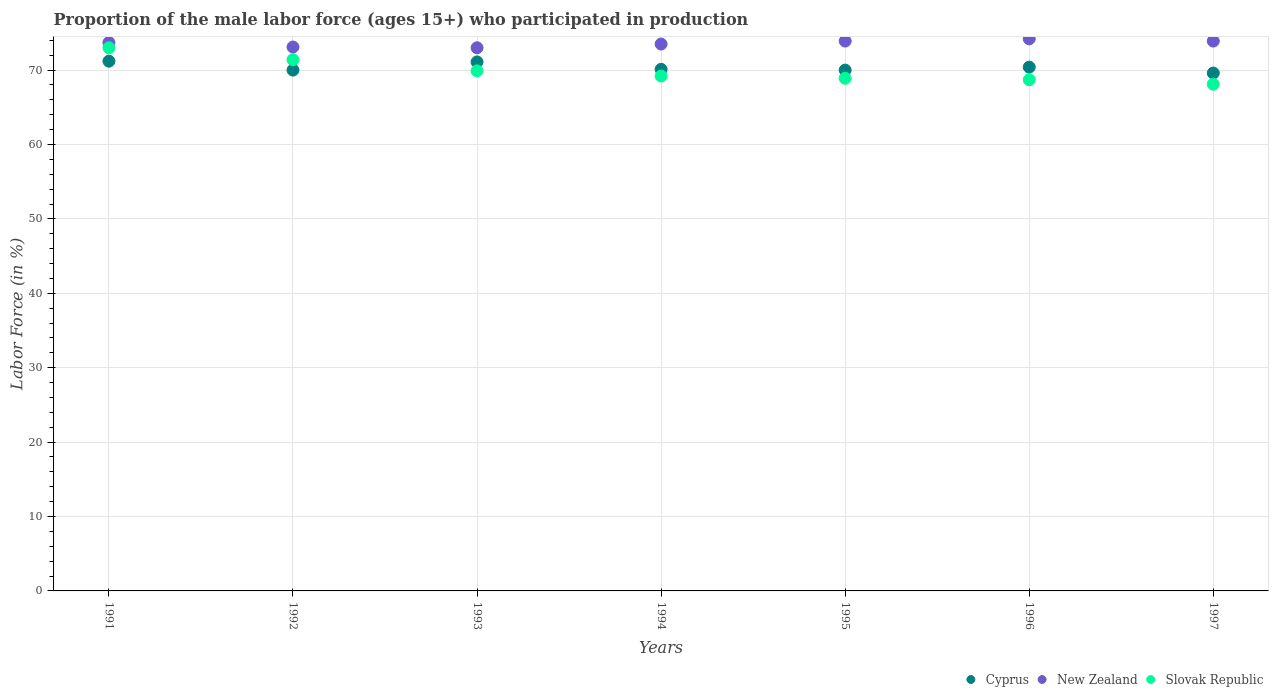How many different coloured dotlines are there?
Your response must be concise. 3. Is the number of dotlines equal to the number of legend labels?
Your answer should be compact. Yes. Across all years, what is the maximum proportion of the male labor force who participated in production in Cyprus?
Provide a short and direct response. 71.2. Across all years, what is the minimum proportion of the male labor force who participated in production in Slovak Republic?
Give a very brief answer. 68.1. In which year was the proportion of the male labor force who participated in production in New Zealand minimum?
Your answer should be compact. 1993. What is the total proportion of the male labor force who participated in production in Cyprus in the graph?
Offer a terse response. 492.4. What is the difference between the proportion of the male labor force who participated in production in Slovak Republic in 1991 and that in 1994?
Ensure brevity in your answer.  3.8. What is the difference between the proportion of the male labor force who participated in production in Slovak Republic in 1992 and the proportion of the male labor force who participated in production in New Zealand in 1996?
Offer a terse response. -2.8. What is the average proportion of the male labor force who participated in production in New Zealand per year?
Make the answer very short. 73.61. In the year 1995, what is the difference between the proportion of the male labor force who participated in production in Slovak Republic and proportion of the male labor force who participated in production in Cyprus?
Offer a terse response. -1.1. In how many years, is the proportion of the male labor force who participated in production in Cyprus greater than 54 %?
Ensure brevity in your answer.  7. What is the ratio of the proportion of the male labor force who participated in production in Slovak Republic in 1991 to that in 1992?
Offer a terse response. 1.02. Is the proportion of the male labor force who participated in production in New Zealand in 1995 less than that in 1997?
Your answer should be compact. No. Is the difference between the proportion of the male labor force who participated in production in Slovak Republic in 1991 and 1997 greater than the difference between the proportion of the male labor force who participated in production in Cyprus in 1991 and 1997?
Keep it short and to the point. Yes. What is the difference between the highest and the second highest proportion of the male labor force who participated in production in New Zealand?
Give a very brief answer. 0.3. What is the difference between the highest and the lowest proportion of the male labor force who participated in production in New Zealand?
Give a very brief answer. 1.2. Is the sum of the proportion of the male labor force who participated in production in New Zealand in 1994 and 1995 greater than the maximum proportion of the male labor force who participated in production in Cyprus across all years?
Make the answer very short. Yes. Does the proportion of the male labor force who participated in production in New Zealand monotonically increase over the years?
Offer a terse response. No. Is the proportion of the male labor force who participated in production in New Zealand strictly greater than the proportion of the male labor force who participated in production in Slovak Republic over the years?
Your response must be concise. Yes. Is the proportion of the male labor force who participated in production in Cyprus strictly less than the proportion of the male labor force who participated in production in New Zealand over the years?
Provide a short and direct response. Yes. How many years are there in the graph?
Give a very brief answer. 7. What is the title of the graph?
Your answer should be compact. Proportion of the male labor force (ages 15+) who participated in production. What is the label or title of the X-axis?
Make the answer very short. Years. What is the label or title of the Y-axis?
Provide a short and direct response. Labor Force (in %). What is the Labor Force (in %) in Cyprus in 1991?
Provide a succinct answer. 71.2. What is the Labor Force (in %) in New Zealand in 1991?
Ensure brevity in your answer.  73.7. What is the Labor Force (in %) in Slovak Republic in 1991?
Offer a terse response. 73. What is the Labor Force (in %) in New Zealand in 1992?
Offer a very short reply. 73.1. What is the Labor Force (in %) in Slovak Republic in 1992?
Your answer should be very brief. 71.4. What is the Labor Force (in %) of Cyprus in 1993?
Make the answer very short. 71.1. What is the Labor Force (in %) of Slovak Republic in 1993?
Provide a short and direct response. 69.9. What is the Labor Force (in %) in Cyprus in 1994?
Make the answer very short. 70.1. What is the Labor Force (in %) of New Zealand in 1994?
Offer a very short reply. 73.5. What is the Labor Force (in %) in Slovak Republic in 1994?
Provide a succinct answer. 69.2. What is the Labor Force (in %) of Cyprus in 1995?
Make the answer very short. 70. What is the Labor Force (in %) of New Zealand in 1995?
Make the answer very short. 73.9. What is the Labor Force (in %) in Slovak Republic in 1995?
Give a very brief answer. 68.9. What is the Labor Force (in %) of Cyprus in 1996?
Make the answer very short. 70.4. What is the Labor Force (in %) in New Zealand in 1996?
Your answer should be compact. 74.2. What is the Labor Force (in %) in Slovak Republic in 1996?
Make the answer very short. 68.7. What is the Labor Force (in %) of Cyprus in 1997?
Make the answer very short. 69.6. What is the Labor Force (in %) of New Zealand in 1997?
Your response must be concise. 73.9. What is the Labor Force (in %) in Slovak Republic in 1997?
Ensure brevity in your answer.  68.1. Across all years, what is the maximum Labor Force (in %) of Cyprus?
Offer a very short reply. 71.2. Across all years, what is the maximum Labor Force (in %) of New Zealand?
Ensure brevity in your answer.  74.2. Across all years, what is the maximum Labor Force (in %) in Slovak Republic?
Offer a terse response. 73. Across all years, what is the minimum Labor Force (in %) of Cyprus?
Your response must be concise. 69.6. Across all years, what is the minimum Labor Force (in %) of New Zealand?
Provide a short and direct response. 73. Across all years, what is the minimum Labor Force (in %) in Slovak Republic?
Your answer should be very brief. 68.1. What is the total Labor Force (in %) in Cyprus in the graph?
Ensure brevity in your answer.  492.4. What is the total Labor Force (in %) in New Zealand in the graph?
Provide a succinct answer. 515.3. What is the total Labor Force (in %) in Slovak Republic in the graph?
Keep it short and to the point. 489.2. What is the difference between the Labor Force (in %) in Cyprus in 1991 and that in 1992?
Keep it short and to the point. 1.2. What is the difference between the Labor Force (in %) of New Zealand in 1991 and that in 1992?
Ensure brevity in your answer.  0.6. What is the difference between the Labor Force (in %) in Slovak Republic in 1991 and that in 1993?
Provide a succinct answer. 3.1. What is the difference between the Labor Force (in %) of Cyprus in 1991 and that in 1994?
Your answer should be very brief. 1.1. What is the difference between the Labor Force (in %) of Slovak Republic in 1991 and that in 1994?
Ensure brevity in your answer.  3.8. What is the difference between the Labor Force (in %) of Cyprus in 1991 and that in 1995?
Your answer should be compact. 1.2. What is the difference between the Labor Force (in %) of Cyprus in 1991 and that in 1996?
Make the answer very short. 0.8. What is the difference between the Labor Force (in %) of New Zealand in 1991 and that in 1996?
Give a very brief answer. -0.5. What is the difference between the Labor Force (in %) of Slovak Republic in 1991 and that in 1996?
Give a very brief answer. 4.3. What is the difference between the Labor Force (in %) of Slovak Republic in 1991 and that in 1997?
Your answer should be compact. 4.9. What is the difference between the Labor Force (in %) in New Zealand in 1992 and that in 1993?
Provide a short and direct response. 0.1. What is the difference between the Labor Force (in %) of Slovak Republic in 1992 and that in 1993?
Offer a terse response. 1.5. What is the difference between the Labor Force (in %) in Cyprus in 1992 and that in 1994?
Your answer should be compact. -0.1. What is the difference between the Labor Force (in %) of Cyprus in 1992 and that in 1995?
Ensure brevity in your answer.  0. What is the difference between the Labor Force (in %) in New Zealand in 1992 and that in 1995?
Your answer should be very brief. -0.8. What is the difference between the Labor Force (in %) in Cyprus in 1992 and that in 1996?
Ensure brevity in your answer.  -0.4. What is the difference between the Labor Force (in %) of New Zealand in 1992 and that in 1996?
Ensure brevity in your answer.  -1.1. What is the difference between the Labor Force (in %) in Slovak Republic in 1992 and that in 1996?
Offer a very short reply. 2.7. What is the difference between the Labor Force (in %) in Cyprus in 1992 and that in 1997?
Keep it short and to the point. 0.4. What is the difference between the Labor Force (in %) of New Zealand in 1992 and that in 1997?
Give a very brief answer. -0.8. What is the difference between the Labor Force (in %) of Slovak Republic in 1992 and that in 1997?
Your answer should be very brief. 3.3. What is the difference between the Labor Force (in %) in New Zealand in 1993 and that in 1994?
Offer a very short reply. -0.5. What is the difference between the Labor Force (in %) of Cyprus in 1993 and that in 1995?
Offer a very short reply. 1.1. What is the difference between the Labor Force (in %) in Slovak Republic in 1993 and that in 1995?
Offer a very short reply. 1. What is the difference between the Labor Force (in %) of Cyprus in 1993 and that in 1996?
Ensure brevity in your answer.  0.7. What is the difference between the Labor Force (in %) in Cyprus in 1994 and that in 1995?
Your response must be concise. 0.1. What is the difference between the Labor Force (in %) of Cyprus in 1994 and that in 1996?
Provide a succinct answer. -0.3. What is the difference between the Labor Force (in %) of Slovak Republic in 1994 and that in 1997?
Give a very brief answer. 1.1. What is the difference between the Labor Force (in %) in New Zealand in 1995 and that in 1996?
Your answer should be very brief. -0.3. What is the difference between the Labor Force (in %) in Slovak Republic in 1995 and that in 1996?
Offer a very short reply. 0.2. What is the difference between the Labor Force (in %) in Cyprus in 1996 and that in 1997?
Your answer should be compact. 0.8. What is the difference between the Labor Force (in %) in Slovak Republic in 1996 and that in 1997?
Keep it short and to the point. 0.6. What is the difference between the Labor Force (in %) of New Zealand in 1991 and the Labor Force (in %) of Slovak Republic in 1993?
Your answer should be compact. 3.8. What is the difference between the Labor Force (in %) in Cyprus in 1991 and the Labor Force (in %) in New Zealand in 1994?
Provide a short and direct response. -2.3. What is the difference between the Labor Force (in %) of New Zealand in 1991 and the Labor Force (in %) of Slovak Republic in 1994?
Offer a very short reply. 4.5. What is the difference between the Labor Force (in %) in Cyprus in 1991 and the Labor Force (in %) in Slovak Republic in 1995?
Ensure brevity in your answer.  2.3. What is the difference between the Labor Force (in %) of Cyprus in 1991 and the Labor Force (in %) of New Zealand in 1996?
Provide a succinct answer. -3. What is the difference between the Labor Force (in %) of Cyprus in 1991 and the Labor Force (in %) of New Zealand in 1997?
Your answer should be very brief. -2.7. What is the difference between the Labor Force (in %) of New Zealand in 1991 and the Labor Force (in %) of Slovak Republic in 1997?
Offer a terse response. 5.6. What is the difference between the Labor Force (in %) in Cyprus in 1992 and the Labor Force (in %) in New Zealand in 1993?
Provide a short and direct response. -3. What is the difference between the Labor Force (in %) of New Zealand in 1992 and the Labor Force (in %) of Slovak Republic in 1993?
Your response must be concise. 3.2. What is the difference between the Labor Force (in %) of Cyprus in 1992 and the Labor Force (in %) of Slovak Republic in 1994?
Keep it short and to the point. 0.8. What is the difference between the Labor Force (in %) of New Zealand in 1992 and the Labor Force (in %) of Slovak Republic in 1994?
Provide a succinct answer. 3.9. What is the difference between the Labor Force (in %) of Cyprus in 1992 and the Labor Force (in %) of Slovak Republic in 1995?
Keep it short and to the point. 1.1. What is the difference between the Labor Force (in %) of Cyprus in 1992 and the Labor Force (in %) of New Zealand in 1996?
Keep it short and to the point. -4.2. What is the difference between the Labor Force (in %) of New Zealand in 1992 and the Labor Force (in %) of Slovak Republic in 1996?
Offer a very short reply. 4.4. What is the difference between the Labor Force (in %) in New Zealand in 1992 and the Labor Force (in %) in Slovak Republic in 1997?
Ensure brevity in your answer.  5. What is the difference between the Labor Force (in %) in Cyprus in 1993 and the Labor Force (in %) in New Zealand in 1994?
Provide a succinct answer. -2.4. What is the difference between the Labor Force (in %) of New Zealand in 1993 and the Labor Force (in %) of Slovak Republic in 1994?
Keep it short and to the point. 3.8. What is the difference between the Labor Force (in %) in Cyprus in 1993 and the Labor Force (in %) in New Zealand in 1995?
Offer a very short reply. -2.8. What is the difference between the Labor Force (in %) of New Zealand in 1993 and the Labor Force (in %) of Slovak Republic in 1995?
Ensure brevity in your answer.  4.1. What is the difference between the Labor Force (in %) in Cyprus in 1993 and the Labor Force (in %) in Slovak Republic in 1996?
Make the answer very short. 2.4. What is the difference between the Labor Force (in %) of New Zealand in 1993 and the Labor Force (in %) of Slovak Republic in 1996?
Keep it short and to the point. 4.3. What is the difference between the Labor Force (in %) of New Zealand in 1993 and the Labor Force (in %) of Slovak Republic in 1997?
Offer a terse response. 4.9. What is the difference between the Labor Force (in %) of Cyprus in 1994 and the Labor Force (in %) of New Zealand in 1995?
Provide a succinct answer. -3.8. What is the difference between the Labor Force (in %) of Cyprus in 1994 and the Labor Force (in %) of Slovak Republic in 1995?
Keep it short and to the point. 1.2. What is the difference between the Labor Force (in %) of New Zealand in 1994 and the Labor Force (in %) of Slovak Republic in 1996?
Provide a short and direct response. 4.8. What is the difference between the Labor Force (in %) of Cyprus in 1994 and the Labor Force (in %) of New Zealand in 1997?
Your answer should be compact. -3.8. What is the difference between the Labor Force (in %) in New Zealand in 1994 and the Labor Force (in %) in Slovak Republic in 1997?
Provide a short and direct response. 5.4. What is the difference between the Labor Force (in %) in Cyprus in 1995 and the Labor Force (in %) in New Zealand in 1996?
Your response must be concise. -4.2. What is the difference between the Labor Force (in %) in New Zealand in 1995 and the Labor Force (in %) in Slovak Republic in 1996?
Keep it short and to the point. 5.2. What is the difference between the Labor Force (in %) of Cyprus in 1995 and the Labor Force (in %) of New Zealand in 1997?
Keep it short and to the point. -3.9. What is the difference between the Labor Force (in %) of Cyprus in 1995 and the Labor Force (in %) of Slovak Republic in 1997?
Your response must be concise. 1.9. What is the average Labor Force (in %) of Cyprus per year?
Your answer should be very brief. 70.34. What is the average Labor Force (in %) of New Zealand per year?
Your response must be concise. 73.61. What is the average Labor Force (in %) in Slovak Republic per year?
Give a very brief answer. 69.89. In the year 1991, what is the difference between the Labor Force (in %) of Cyprus and Labor Force (in %) of New Zealand?
Offer a terse response. -2.5. In the year 1991, what is the difference between the Labor Force (in %) of Cyprus and Labor Force (in %) of Slovak Republic?
Keep it short and to the point. -1.8. In the year 1992, what is the difference between the Labor Force (in %) of Cyprus and Labor Force (in %) of Slovak Republic?
Your answer should be very brief. -1.4. In the year 1993, what is the difference between the Labor Force (in %) in Cyprus and Labor Force (in %) in New Zealand?
Offer a very short reply. -1.9. In the year 1993, what is the difference between the Labor Force (in %) of Cyprus and Labor Force (in %) of Slovak Republic?
Keep it short and to the point. 1.2. In the year 1993, what is the difference between the Labor Force (in %) in New Zealand and Labor Force (in %) in Slovak Republic?
Offer a very short reply. 3.1. In the year 1994, what is the difference between the Labor Force (in %) in Cyprus and Labor Force (in %) in New Zealand?
Offer a very short reply. -3.4. In the year 1994, what is the difference between the Labor Force (in %) in New Zealand and Labor Force (in %) in Slovak Republic?
Make the answer very short. 4.3. In the year 1995, what is the difference between the Labor Force (in %) of Cyprus and Labor Force (in %) of Slovak Republic?
Your response must be concise. 1.1. In the year 1995, what is the difference between the Labor Force (in %) of New Zealand and Labor Force (in %) of Slovak Republic?
Offer a very short reply. 5. In the year 1996, what is the difference between the Labor Force (in %) of Cyprus and Labor Force (in %) of Slovak Republic?
Keep it short and to the point. 1.7. In the year 1996, what is the difference between the Labor Force (in %) of New Zealand and Labor Force (in %) of Slovak Republic?
Provide a short and direct response. 5.5. In the year 1997, what is the difference between the Labor Force (in %) of Cyprus and Labor Force (in %) of New Zealand?
Offer a terse response. -4.3. In the year 1997, what is the difference between the Labor Force (in %) in New Zealand and Labor Force (in %) in Slovak Republic?
Offer a very short reply. 5.8. What is the ratio of the Labor Force (in %) in Cyprus in 1991 to that in 1992?
Offer a terse response. 1.02. What is the ratio of the Labor Force (in %) in New Zealand in 1991 to that in 1992?
Provide a succinct answer. 1.01. What is the ratio of the Labor Force (in %) in Slovak Republic in 1991 to that in 1992?
Your answer should be compact. 1.02. What is the ratio of the Labor Force (in %) of New Zealand in 1991 to that in 1993?
Make the answer very short. 1.01. What is the ratio of the Labor Force (in %) in Slovak Republic in 1991 to that in 1993?
Your answer should be very brief. 1.04. What is the ratio of the Labor Force (in %) of Cyprus in 1991 to that in 1994?
Provide a short and direct response. 1.02. What is the ratio of the Labor Force (in %) of New Zealand in 1991 to that in 1994?
Offer a terse response. 1. What is the ratio of the Labor Force (in %) in Slovak Republic in 1991 to that in 1994?
Give a very brief answer. 1.05. What is the ratio of the Labor Force (in %) of Cyprus in 1991 to that in 1995?
Offer a very short reply. 1.02. What is the ratio of the Labor Force (in %) in New Zealand in 1991 to that in 1995?
Make the answer very short. 1. What is the ratio of the Labor Force (in %) in Slovak Republic in 1991 to that in 1995?
Your response must be concise. 1.06. What is the ratio of the Labor Force (in %) in Cyprus in 1991 to that in 1996?
Give a very brief answer. 1.01. What is the ratio of the Labor Force (in %) in New Zealand in 1991 to that in 1996?
Give a very brief answer. 0.99. What is the ratio of the Labor Force (in %) of Slovak Republic in 1991 to that in 1996?
Your response must be concise. 1.06. What is the ratio of the Labor Force (in %) of New Zealand in 1991 to that in 1997?
Give a very brief answer. 1. What is the ratio of the Labor Force (in %) in Slovak Republic in 1991 to that in 1997?
Your answer should be compact. 1.07. What is the ratio of the Labor Force (in %) in Cyprus in 1992 to that in 1993?
Provide a succinct answer. 0.98. What is the ratio of the Labor Force (in %) of New Zealand in 1992 to that in 1993?
Offer a very short reply. 1. What is the ratio of the Labor Force (in %) of Slovak Republic in 1992 to that in 1993?
Your response must be concise. 1.02. What is the ratio of the Labor Force (in %) in Cyprus in 1992 to that in 1994?
Your answer should be compact. 1. What is the ratio of the Labor Force (in %) of Slovak Republic in 1992 to that in 1994?
Provide a succinct answer. 1.03. What is the ratio of the Labor Force (in %) in Cyprus in 1992 to that in 1995?
Keep it short and to the point. 1. What is the ratio of the Labor Force (in %) in New Zealand in 1992 to that in 1995?
Your answer should be compact. 0.99. What is the ratio of the Labor Force (in %) of Slovak Republic in 1992 to that in 1995?
Provide a short and direct response. 1.04. What is the ratio of the Labor Force (in %) in Cyprus in 1992 to that in 1996?
Provide a succinct answer. 0.99. What is the ratio of the Labor Force (in %) of New Zealand in 1992 to that in 1996?
Offer a terse response. 0.99. What is the ratio of the Labor Force (in %) in Slovak Republic in 1992 to that in 1996?
Offer a terse response. 1.04. What is the ratio of the Labor Force (in %) in New Zealand in 1992 to that in 1997?
Your answer should be very brief. 0.99. What is the ratio of the Labor Force (in %) of Slovak Republic in 1992 to that in 1997?
Offer a terse response. 1.05. What is the ratio of the Labor Force (in %) of Cyprus in 1993 to that in 1994?
Offer a terse response. 1.01. What is the ratio of the Labor Force (in %) in New Zealand in 1993 to that in 1994?
Keep it short and to the point. 0.99. What is the ratio of the Labor Force (in %) in Cyprus in 1993 to that in 1995?
Ensure brevity in your answer.  1.02. What is the ratio of the Labor Force (in %) in Slovak Republic in 1993 to that in 1995?
Offer a very short reply. 1.01. What is the ratio of the Labor Force (in %) in Cyprus in 1993 to that in 1996?
Offer a terse response. 1.01. What is the ratio of the Labor Force (in %) in New Zealand in 1993 to that in 1996?
Your answer should be compact. 0.98. What is the ratio of the Labor Force (in %) of Slovak Republic in 1993 to that in 1996?
Offer a very short reply. 1.02. What is the ratio of the Labor Force (in %) in Cyprus in 1993 to that in 1997?
Keep it short and to the point. 1.02. What is the ratio of the Labor Force (in %) of Slovak Republic in 1993 to that in 1997?
Provide a short and direct response. 1.03. What is the ratio of the Labor Force (in %) in Cyprus in 1994 to that in 1995?
Your answer should be very brief. 1. What is the ratio of the Labor Force (in %) of Cyprus in 1994 to that in 1996?
Your answer should be compact. 1. What is the ratio of the Labor Force (in %) of New Zealand in 1994 to that in 1996?
Provide a succinct answer. 0.99. What is the ratio of the Labor Force (in %) of Slovak Republic in 1994 to that in 1996?
Offer a terse response. 1.01. What is the ratio of the Labor Force (in %) of Cyprus in 1994 to that in 1997?
Offer a terse response. 1.01. What is the ratio of the Labor Force (in %) of Slovak Republic in 1994 to that in 1997?
Offer a very short reply. 1.02. What is the ratio of the Labor Force (in %) of New Zealand in 1995 to that in 1996?
Ensure brevity in your answer.  1. What is the ratio of the Labor Force (in %) of Slovak Republic in 1995 to that in 1996?
Provide a succinct answer. 1. What is the ratio of the Labor Force (in %) in Cyprus in 1995 to that in 1997?
Give a very brief answer. 1.01. What is the ratio of the Labor Force (in %) in Slovak Republic in 1995 to that in 1997?
Offer a terse response. 1.01. What is the ratio of the Labor Force (in %) of Cyprus in 1996 to that in 1997?
Keep it short and to the point. 1.01. What is the ratio of the Labor Force (in %) in New Zealand in 1996 to that in 1997?
Your answer should be very brief. 1. What is the ratio of the Labor Force (in %) in Slovak Republic in 1996 to that in 1997?
Your answer should be compact. 1.01. What is the difference between the highest and the second highest Labor Force (in %) of New Zealand?
Keep it short and to the point. 0.3. 